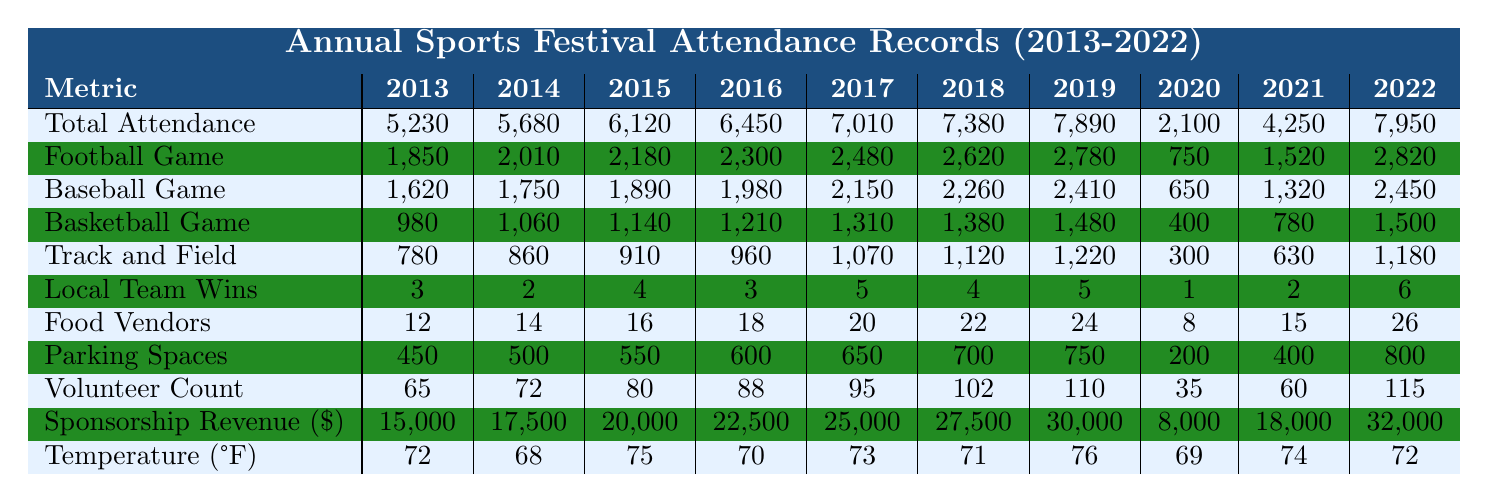What was the total attendance in 2022? The table shows the total attendance for each year, and in 2022 it is listed as 7,950.
Answer: 7,950 How many local team wins were recorded in 2015? Referring to the 2015 row in the table, the local team wins are noted as 4.
Answer: 4 What was the highest attendance for a football game, and in which year did it occur? Checking the Football Game Attendance row, the highest attendance is 2,780 in 2019.
Answer: 2,780 in 2019 What is the average attendance across all sports for 2020? The total attendance for 2020 is 2,100. For an average, we divide by the number of sports (4: football, baseball, basketball, track and field). Sum of attendance for 2020 is 750 + 650 + 400 + 300 = 2,100, thus the average is 2,100/4 = 525.
Answer: 525 Was there a year when attendance dropped below 3,000? In the table, the only year where total attendance was below 3,000 is 2020 with an attendance of 2,100.
Answer: Yes How many total attendees were there over the decade from 2013 to 2022? We sum the total attendance from 2013 to 2022: 5,230 + 5,680 + 6,120 + 6,450 + 7,010 + 7,380 + 7,890 + 2,100 + 4,250 + 7,950 = 59,060.
Answer: 59,060 In how many of the years did the local team win more than 4 games? Looking at the Local Team Wins row, the years with more than 4 wins are 2017, 2018, and 2022, which is 3 years total.
Answer: 3 What was the total number of food vendors in the festival in 2019? The table indicates that there were 24 food vendors in 2019.
Answer: 24 How did the attendance of the 2021 football game compare to that of 2019? The 2021 football game attendance is 1,520, while in 2019 it was 2,780. The difference is 2,780 - 1,520 = 1,260, indicating attendance dropped by that amount.
Answer: Dropped by 1,260 Which year had the highest sponsorship revenue? Reviewing the Sponsorship Revenue row, the year with the highest revenue is 2022, with an amount of 32,000 USD.
Answer: 2022 Was the temperature cooler or warmer than 70°F in 2014? The table lists the temperature in 2014 as 68°F, which is cooler than 70°F.
Answer: Cooler 